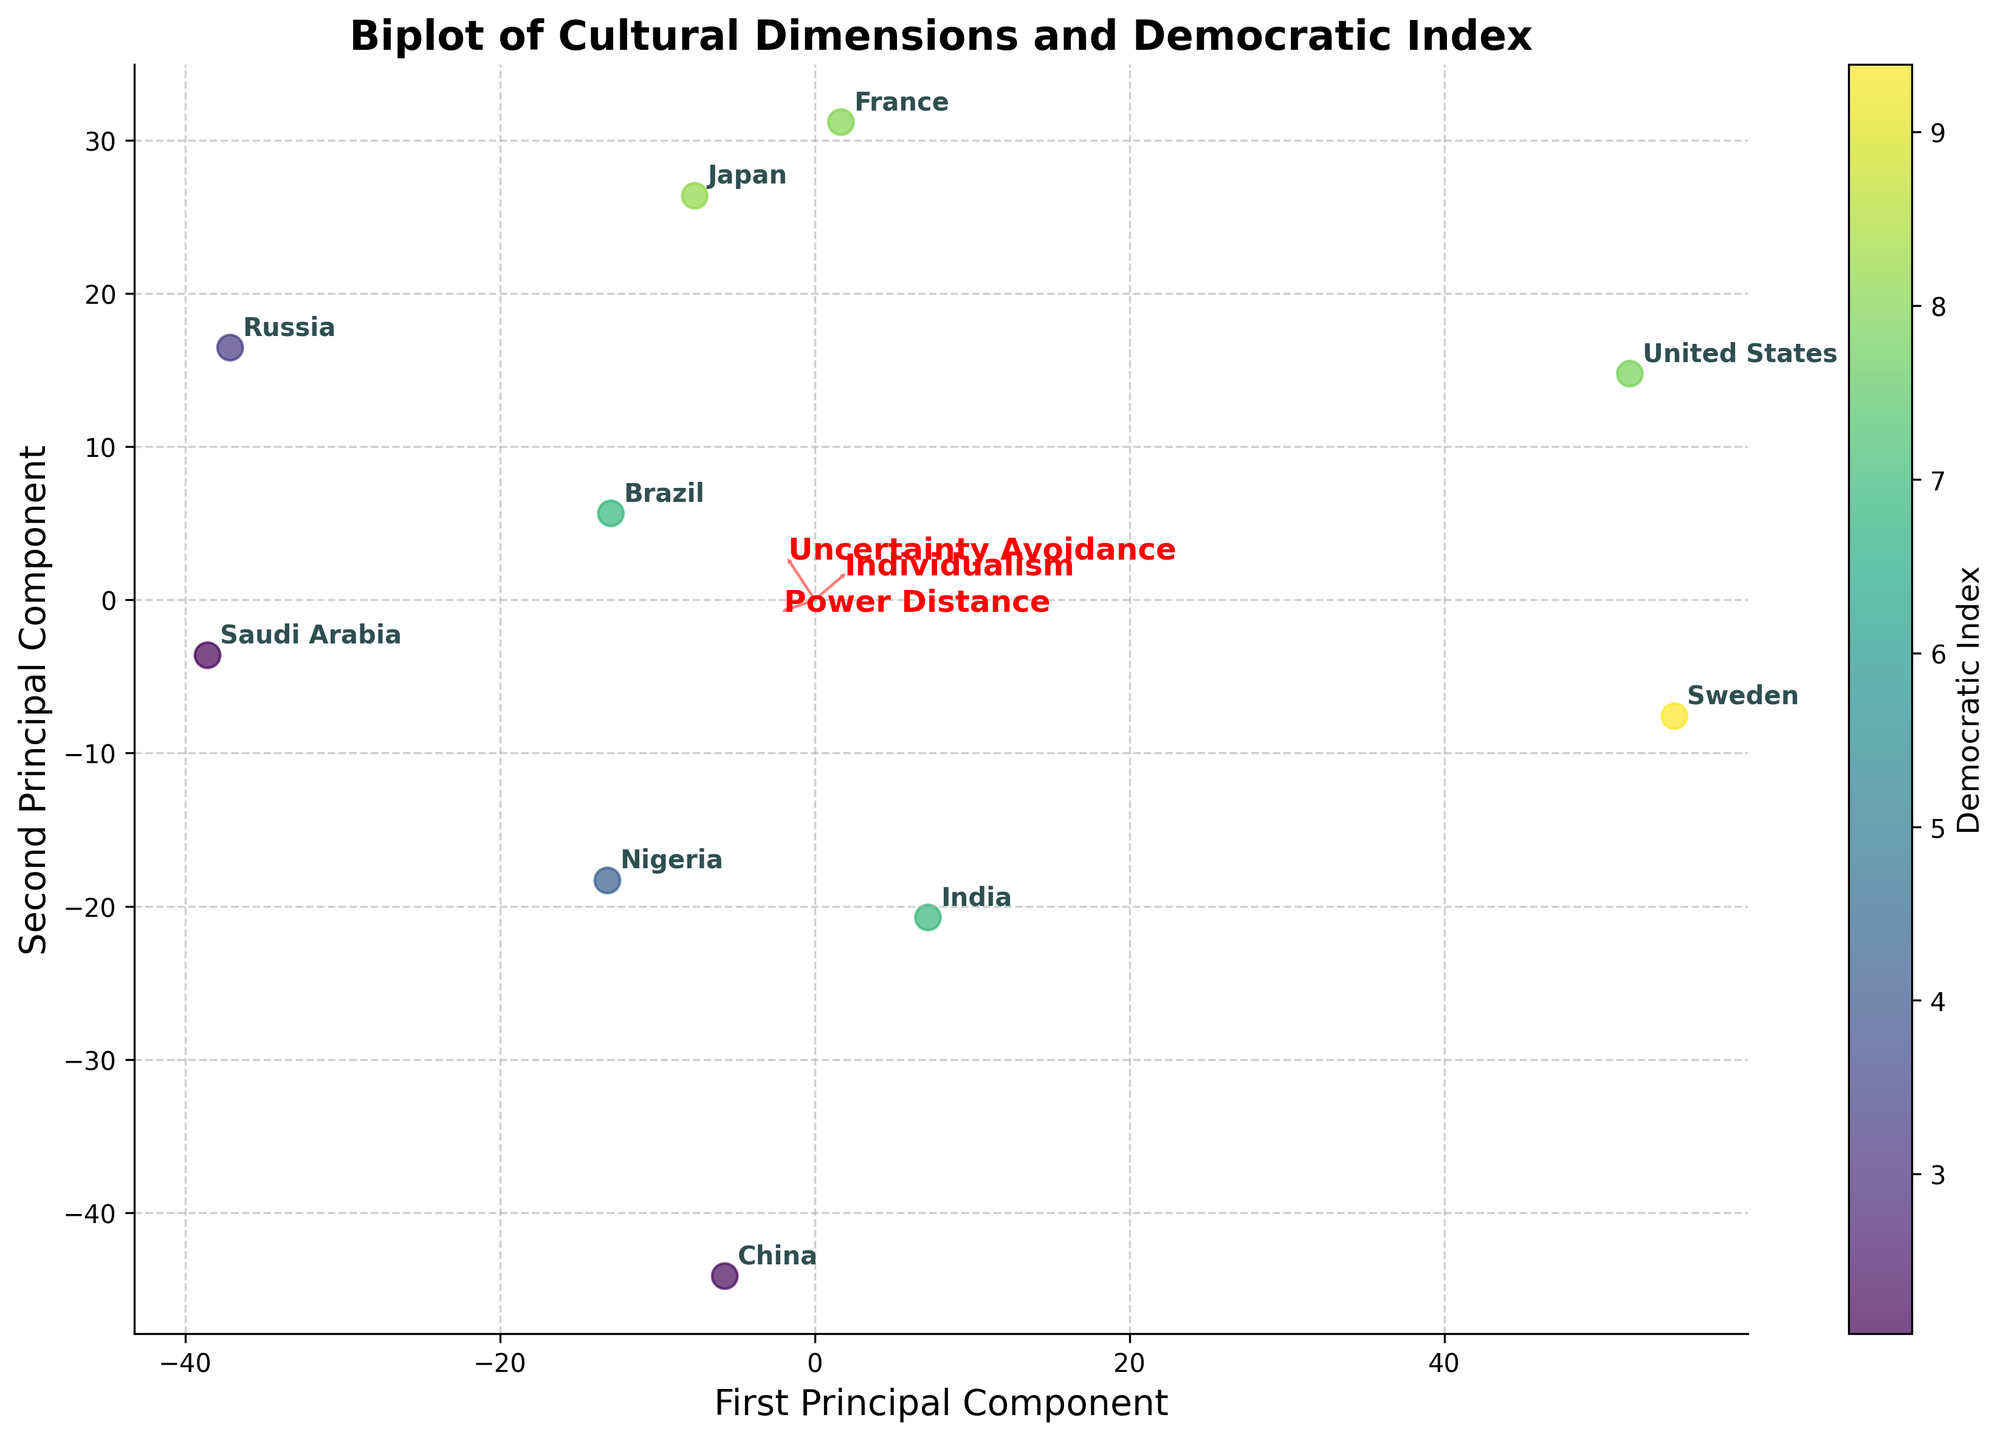What is the title of the biplot? The title is located at the top of the figure and describes the main topic of the biplot, which helps in understanding what the figure is about.
Answer: Biplot of Cultural Dimensions and Democratic Index How many countries are analyzed in this biplot? By counting the number of distinct labels on the biplot, one can determine the number of countries included in the analysis.
Answer: 10 Which country has the highest democratic index, and where is it positioned on the plot? By looking for the country label associated with the highest value on the colorbar, we can identify the country and its position on the plot.
Answer: Sweden, top-left What are the axes labels in the biplot? The labels of the axes provide context for what the principal components represent in the data, which can show relationships between variables.
Answer: First Principal Component, Second Principal Component Which cultural dimension seems to have the strongest correlation with the first principal component, based on the direction of the arrows? By examining the direction and length of the arrows representing the cultural dimensions, we can infer the correlation with the principal components.
Answer: Individualism How does Brazil's position in the biplot compare to Russia in terms of the first principal component? By locating Brazil and Russia on the plot, one can compare their positions relative to the First Principal Component to understand how they differ in that dimension.
Answer: Brazil is closer to the origin on the first principal component compared to Russia, indicating lower values Are there countries that combine a low power distance with a high democratic index? Name one. By investigating the positions and corresponding labels in the plot, we can identify which countries have low power distance values (based on arrow directions) and high democratic index values (based on color).
Answer: Sweden What does a longer arrow for a cultural dimension indicate in the biplot? The length of the arrow in biplots typically reflects the importance or contribution of that particular dimension to the principal components. Longer arrows indicate a stronger influence.
Answer: Stronger influence on principal components Which two countries are positioned closest to each other on the biplot, and what might this suggest about their cultural dimensions? By observing the spatial proximity between country labels, one can deduce which countries are most similar in terms of the first two principal components, suggesting similarities in cultural dimensions.
Answer: Brazil and Nigeria, suggesting similar cultural dimensions How is the concept of 'Civil Liberties' indicated in this biplot? Civil Liberties are not directly indicated as vectors or components in the plot; however, it might correlate with the Democratic Index, which is represented through colors.
Answer: Through colorbar correlated with Democratic Index 